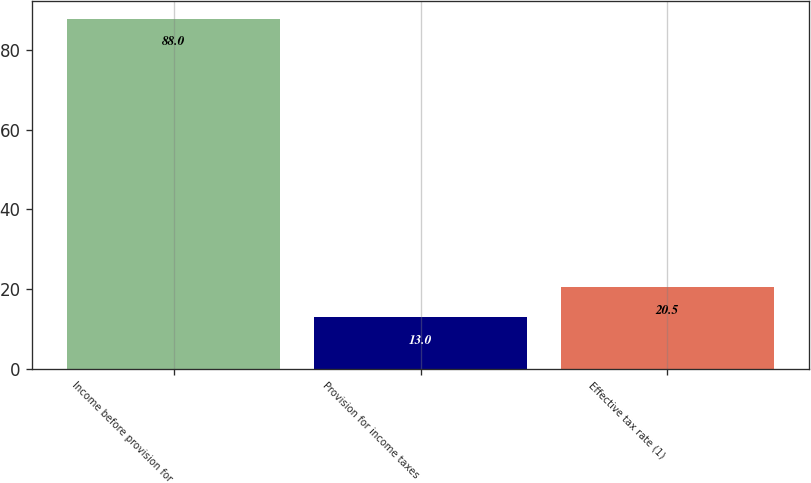<chart> <loc_0><loc_0><loc_500><loc_500><bar_chart><fcel>Income before provision for<fcel>Provision for income taxes<fcel>Effective tax rate (1)<nl><fcel>88<fcel>13<fcel>20.5<nl></chart> 